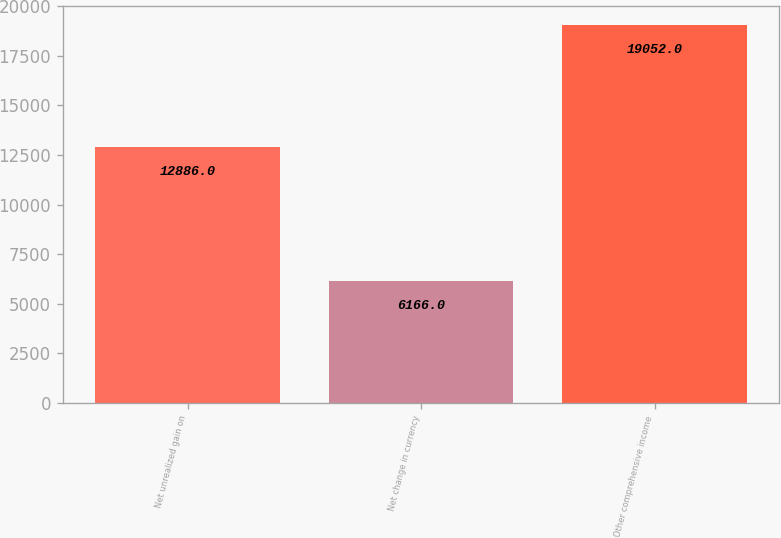Convert chart. <chart><loc_0><loc_0><loc_500><loc_500><bar_chart><fcel>Net unrealized gain on<fcel>Net change in currency<fcel>Other comprehensive income<nl><fcel>12886<fcel>6166<fcel>19052<nl></chart> 